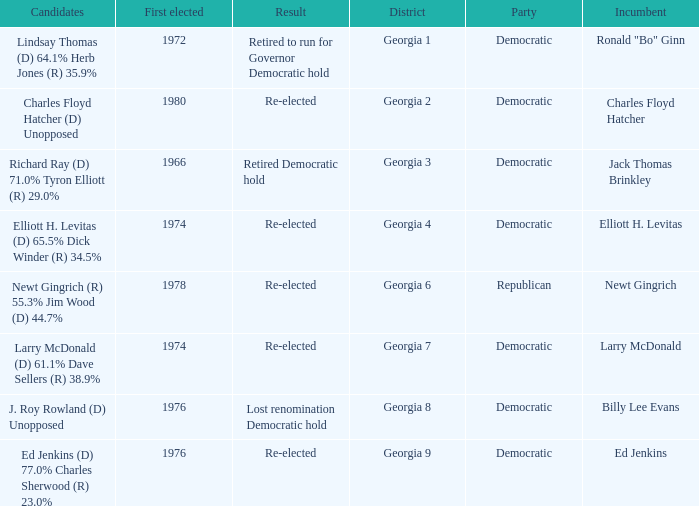Name the districk for larry mcdonald Georgia 7. 